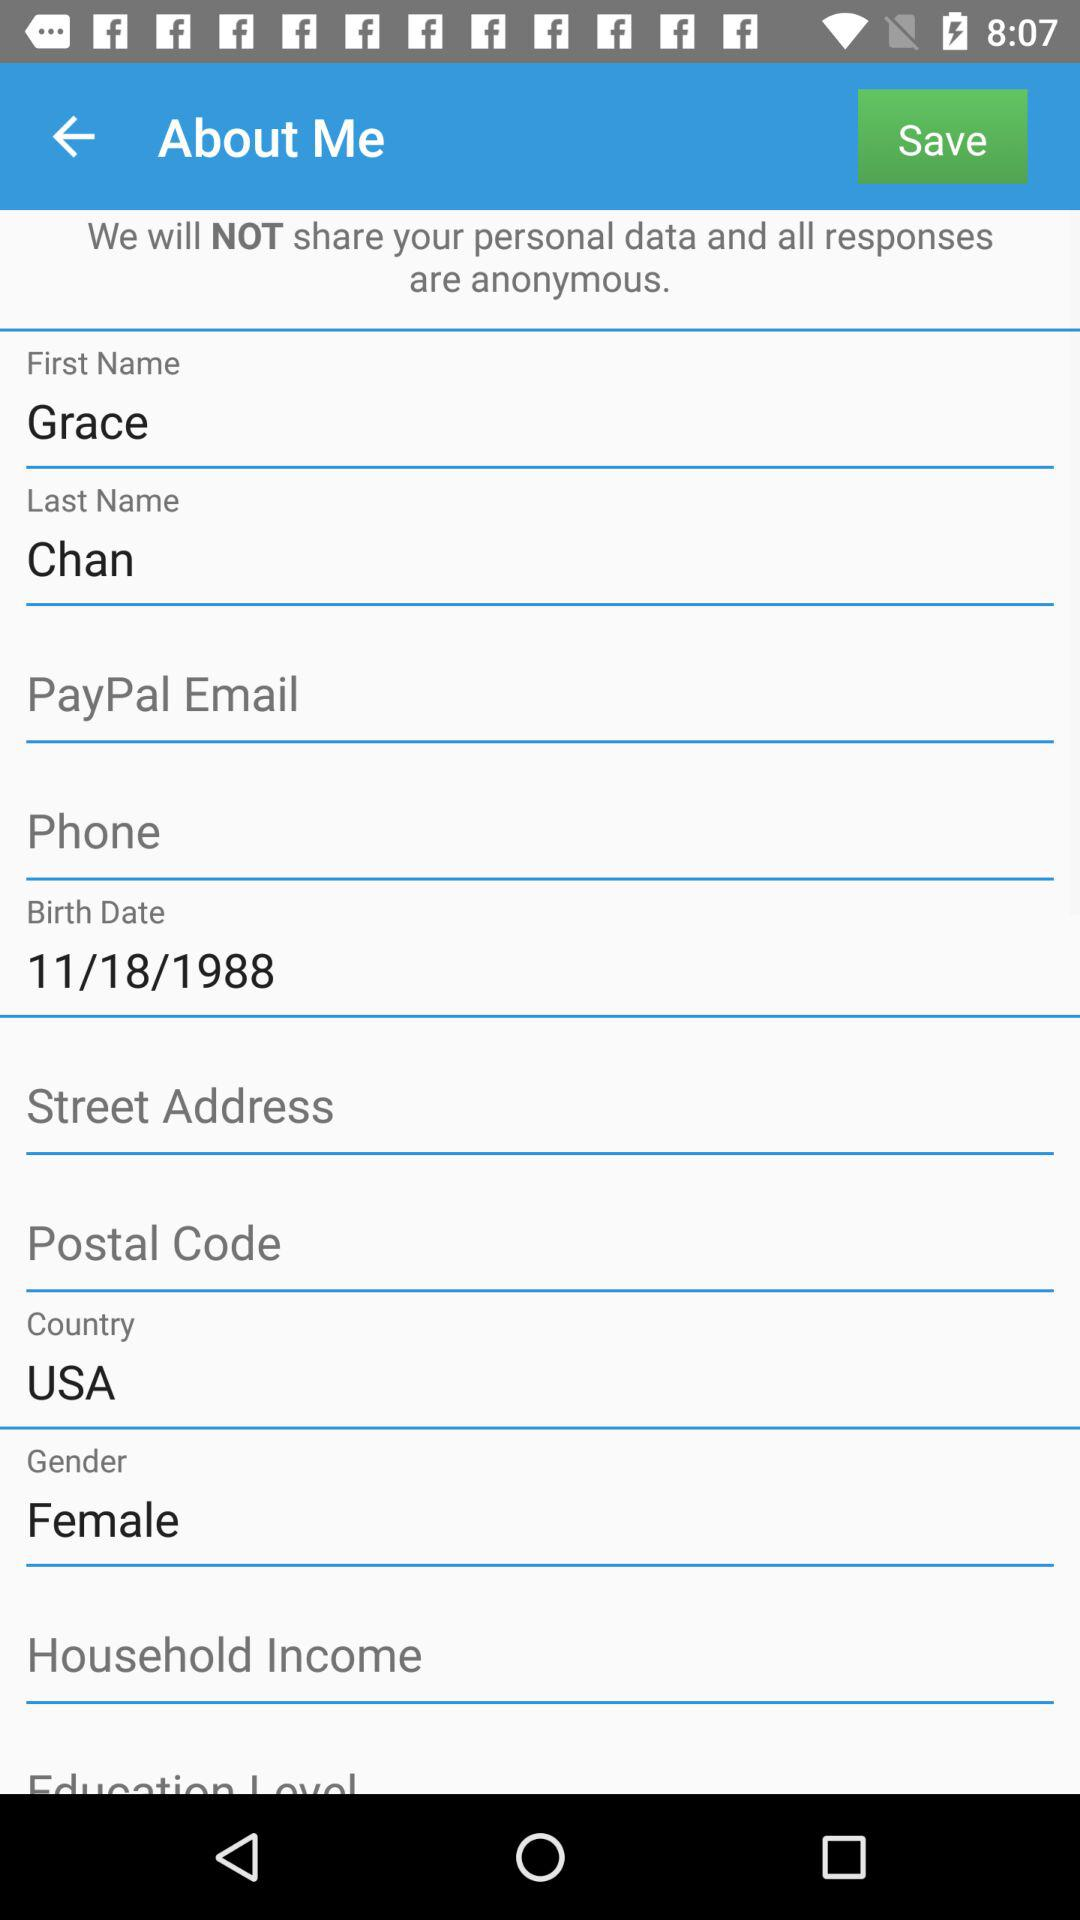What is the name of the user? The name of the user is Grace Chan. 